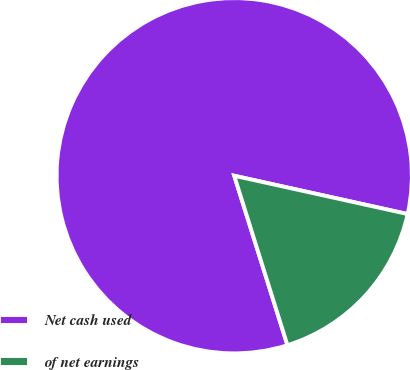Convert chart to OTSL. <chart><loc_0><loc_0><loc_500><loc_500><pie_chart><fcel>Net cash used<fcel>of net earnings<nl><fcel>83.3%<fcel>16.7%<nl></chart> 